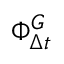<formula> <loc_0><loc_0><loc_500><loc_500>\Phi _ { \Delta { t } } ^ { G }</formula> 